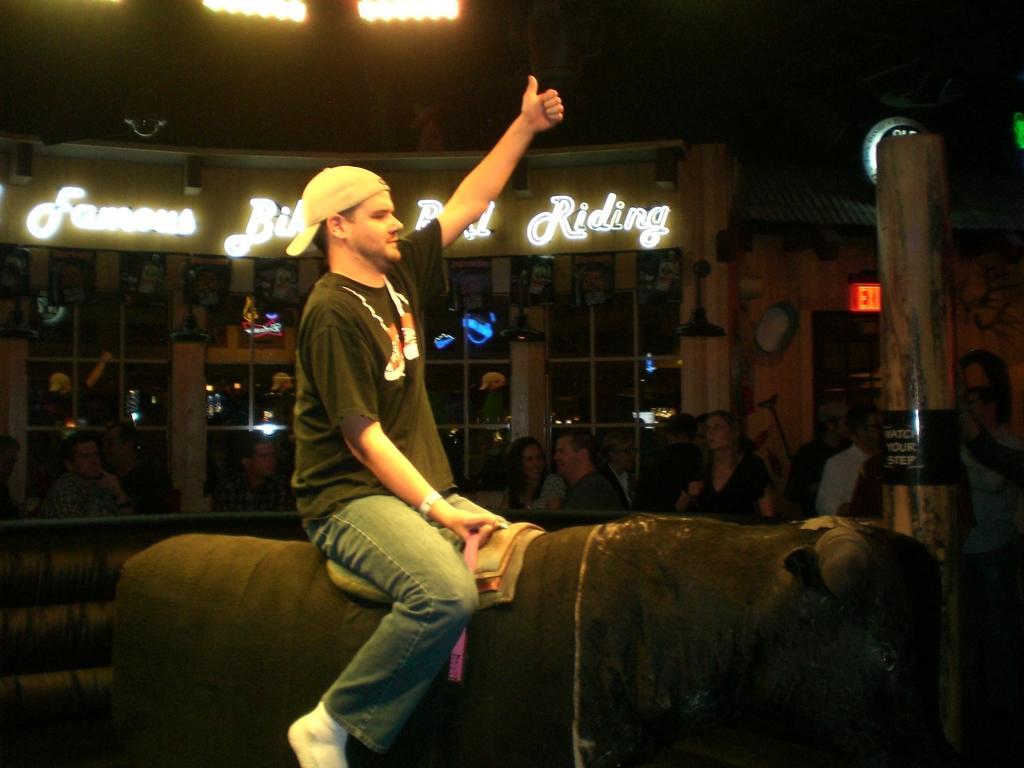In one or two sentences, can you explain what this image depicts? Here we can see a person playing rodeo bull game and he wore a cap. In the background we can see few persons, pillar, boards, lights, and glasses. 